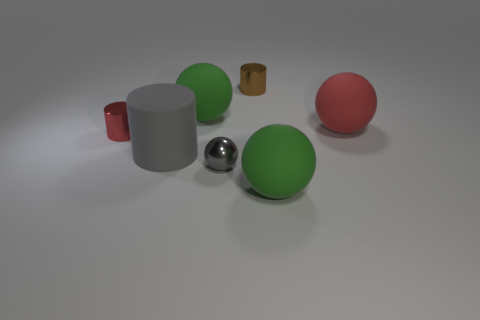Subtract all green cylinders. How many green spheres are left? 2 Add 1 gray cylinders. How many objects exist? 8 Subtract all gray metal spheres. How many spheres are left? 3 Subtract all green balls. How many balls are left? 2 Subtract all cylinders. How many objects are left? 4 Subtract 3 balls. How many balls are left? 1 Subtract all tiny red metallic objects. Subtract all red cylinders. How many objects are left? 5 Add 7 green balls. How many green balls are left? 9 Add 4 red metal objects. How many red metal objects exist? 5 Subtract 0 gray cubes. How many objects are left? 7 